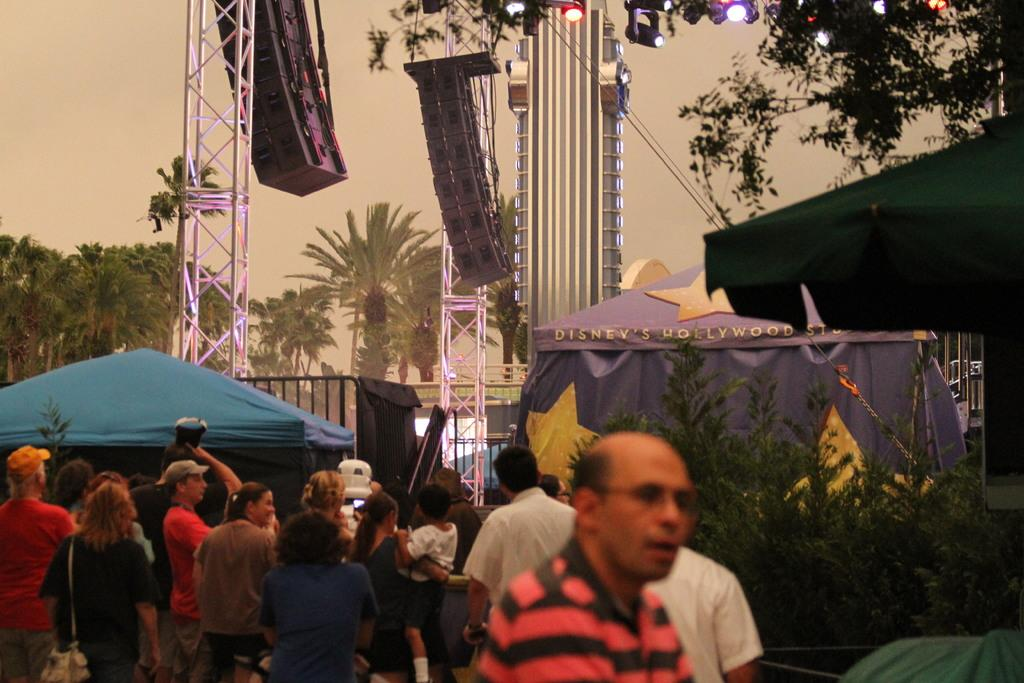How many people are in the image? There is a group of people in the image. What structures can be seen in the image? There are tents and towers in the image. What type of natural elements are present in the image? There are trees in the image. What is visible in the sky in the image? The sky is visible in the image. What additional feature can be seen at the top of the image? There are colorful lights at the top of the image. Can you tell me where the aunt is sitting in the image? There is no mention of an aunt in the image, so we cannot determine her location. What type of cloth is draped over the tents in the image? There is no mention of cloth draped over the tents in the image. 